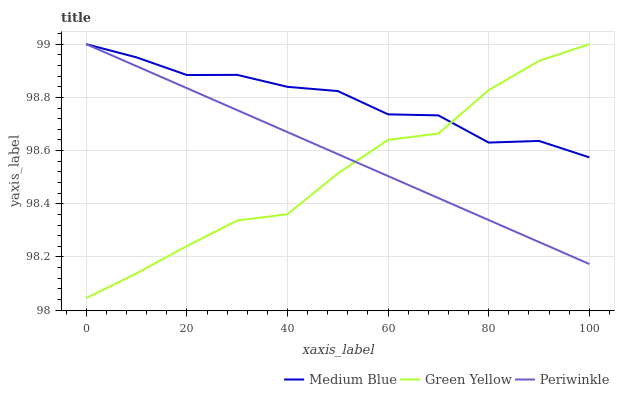Does Green Yellow have the minimum area under the curve?
Answer yes or no. Yes. Does Medium Blue have the maximum area under the curve?
Answer yes or no. Yes. Does Medium Blue have the minimum area under the curve?
Answer yes or no. No. Does Green Yellow have the maximum area under the curve?
Answer yes or no. No. Is Periwinkle the smoothest?
Answer yes or no. Yes. Is Medium Blue the roughest?
Answer yes or no. Yes. Is Green Yellow the smoothest?
Answer yes or no. No. Is Green Yellow the roughest?
Answer yes or no. No. Does Green Yellow have the lowest value?
Answer yes or no. Yes. Does Medium Blue have the lowest value?
Answer yes or no. No. Does Medium Blue have the highest value?
Answer yes or no. Yes. Does Medium Blue intersect Periwinkle?
Answer yes or no. Yes. Is Medium Blue less than Periwinkle?
Answer yes or no. No. Is Medium Blue greater than Periwinkle?
Answer yes or no. No. 